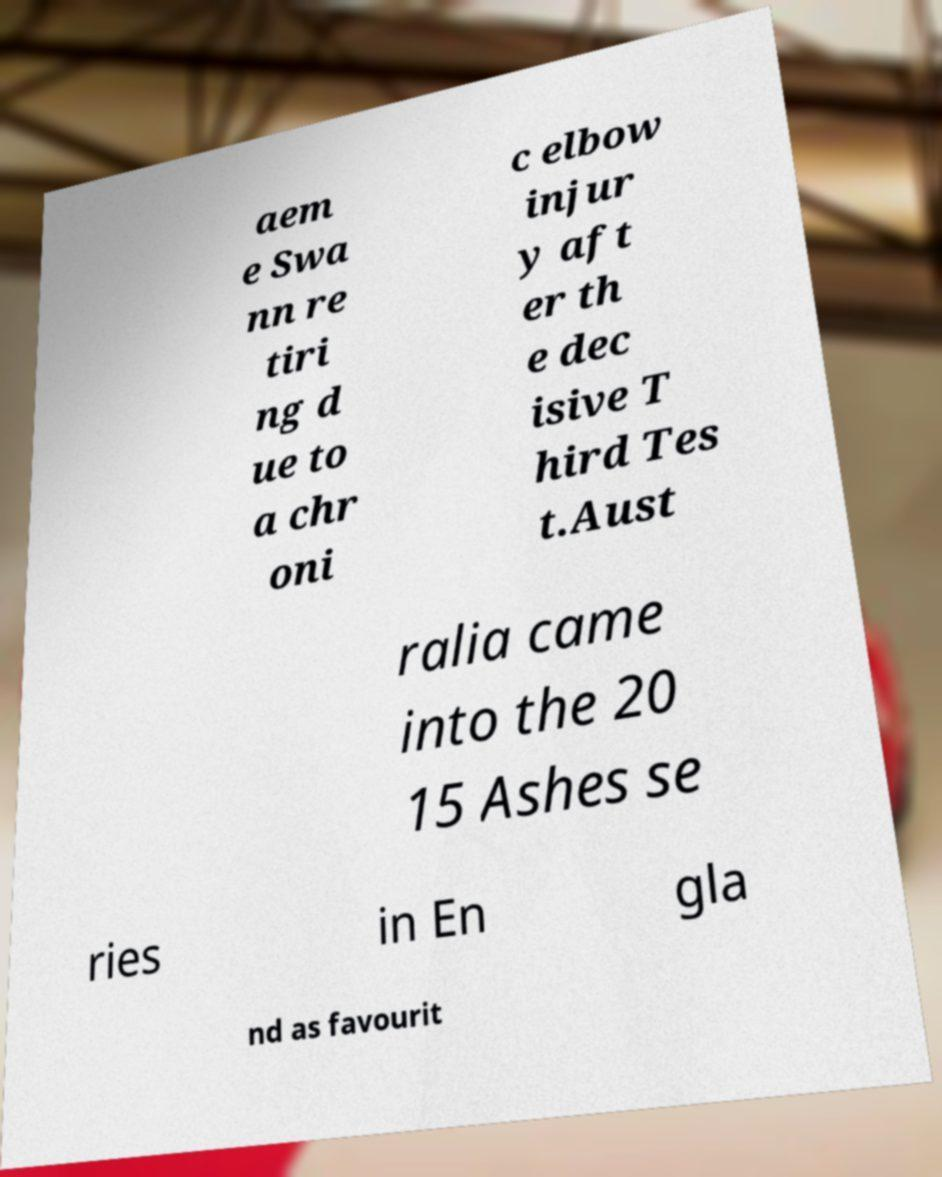For documentation purposes, I need the text within this image transcribed. Could you provide that? aem e Swa nn re tiri ng d ue to a chr oni c elbow injur y aft er th e dec isive T hird Tes t.Aust ralia came into the 20 15 Ashes se ries in En gla nd as favourit 